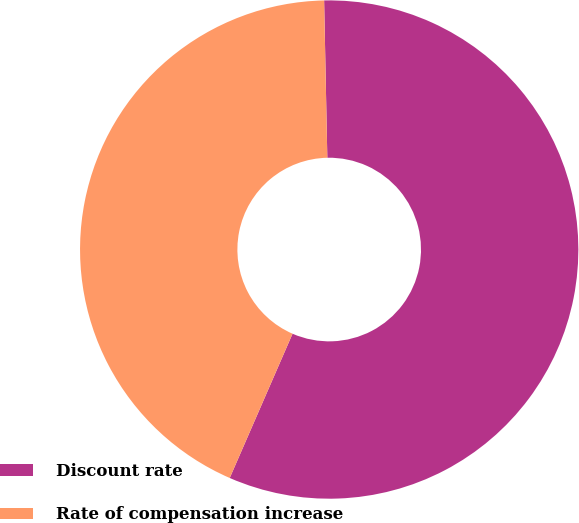Convert chart. <chart><loc_0><loc_0><loc_500><loc_500><pie_chart><fcel>Discount rate<fcel>Rate of compensation increase<nl><fcel>56.86%<fcel>43.14%<nl></chart> 